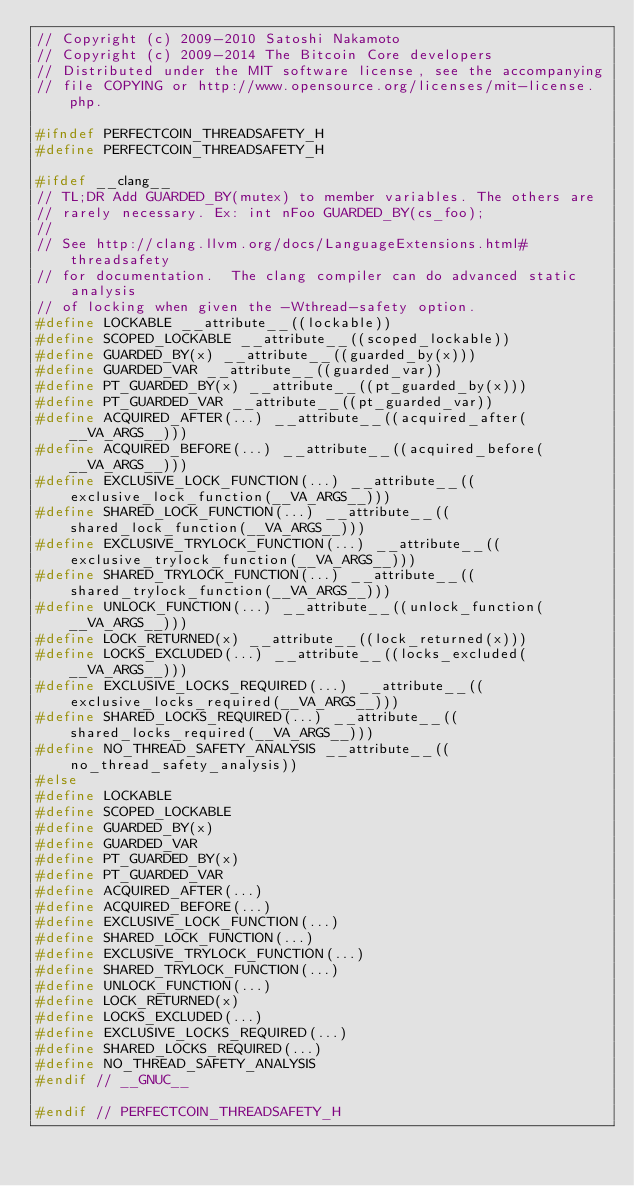Convert code to text. <code><loc_0><loc_0><loc_500><loc_500><_C_>// Copyright (c) 2009-2010 Satoshi Nakamoto
// Copyright (c) 2009-2014 The Bitcoin Core developers
// Distributed under the MIT software license, see the accompanying
// file COPYING or http://www.opensource.org/licenses/mit-license.php.

#ifndef PERFECTCOIN_THREADSAFETY_H
#define PERFECTCOIN_THREADSAFETY_H

#ifdef __clang__
// TL;DR Add GUARDED_BY(mutex) to member variables. The others are
// rarely necessary. Ex: int nFoo GUARDED_BY(cs_foo);
//
// See http://clang.llvm.org/docs/LanguageExtensions.html#threadsafety
// for documentation.  The clang compiler can do advanced static analysis
// of locking when given the -Wthread-safety option.
#define LOCKABLE __attribute__((lockable))
#define SCOPED_LOCKABLE __attribute__((scoped_lockable))
#define GUARDED_BY(x) __attribute__((guarded_by(x)))
#define GUARDED_VAR __attribute__((guarded_var))
#define PT_GUARDED_BY(x) __attribute__((pt_guarded_by(x)))
#define PT_GUARDED_VAR __attribute__((pt_guarded_var))
#define ACQUIRED_AFTER(...) __attribute__((acquired_after(__VA_ARGS__)))
#define ACQUIRED_BEFORE(...) __attribute__((acquired_before(__VA_ARGS__)))
#define EXCLUSIVE_LOCK_FUNCTION(...) __attribute__((exclusive_lock_function(__VA_ARGS__)))
#define SHARED_LOCK_FUNCTION(...) __attribute__((shared_lock_function(__VA_ARGS__)))
#define EXCLUSIVE_TRYLOCK_FUNCTION(...) __attribute__((exclusive_trylock_function(__VA_ARGS__)))
#define SHARED_TRYLOCK_FUNCTION(...) __attribute__((shared_trylock_function(__VA_ARGS__)))
#define UNLOCK_FUNCTION(...) __attribute__((unlock_function(__VA_ARGS__)))
#define LOCK_RETURNED(x) __attribute__((lock_returned(x)))
#define LOCKS_EXCLUDED(...) __attribute__((locks_excluded(__VA_ARGS__)))
#define EXCLUSIVE_LOCKS_REQUIRED(...) __attribute__((exclusive_locks_required(__VA_ARGS__)))
#define SHARED_LOCKS_REQUIRED(...) __attribute__((shared_locks_required(__VA_ARGS__)))
#define NO_THREAD_SAFETY_ANALYSIS __attribute__((no_thread_safety_analysis))
#else
#define LOCKABLE
#define SCOPED_LOCKABLE
#define GUARDED_BY(x)
#define GUARDED_VAR
#define PT_GUARDED_BY(x)
#define PT_GUARDED_VAR
#define ACQUIRED_AFTER(...)
#define ACQUIRED_BEFORE(...)
#define EXCLUSIVE_LOCK_FUNCTION(...)
#define SHARED_LOCK_FUNCTION(...)
#define EXCLUSIVE_TRYLOCK_FUNCTION(...)
#define SHARED_TRYLOCK_FUNCTION(...)
#define UNLOCK_FUNCTION(...)
#define LOCK_RETURNED(x)
#define LOCKS_EXCLUDED(...)
#define EXCLUSIVE_LOCKS_REQUIRED(...)
#define SHARED_LOCKS_REQUIRED(...)
#define NO_THREAD_SAFETY_ANALYSIS
#endif // __GNUC__

#endif // PERFECTCOIN_THREADSAFETY_H
</code> 